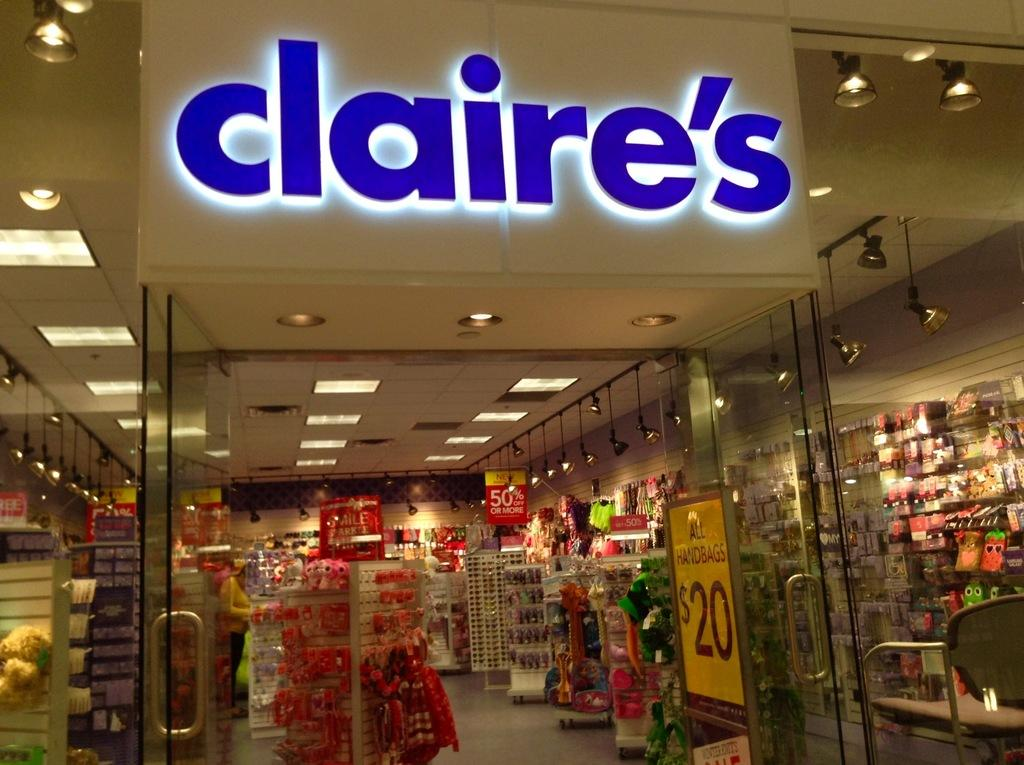Provide a one-sentence caption for the provided image. A Claire's store in a mall is open for business. 